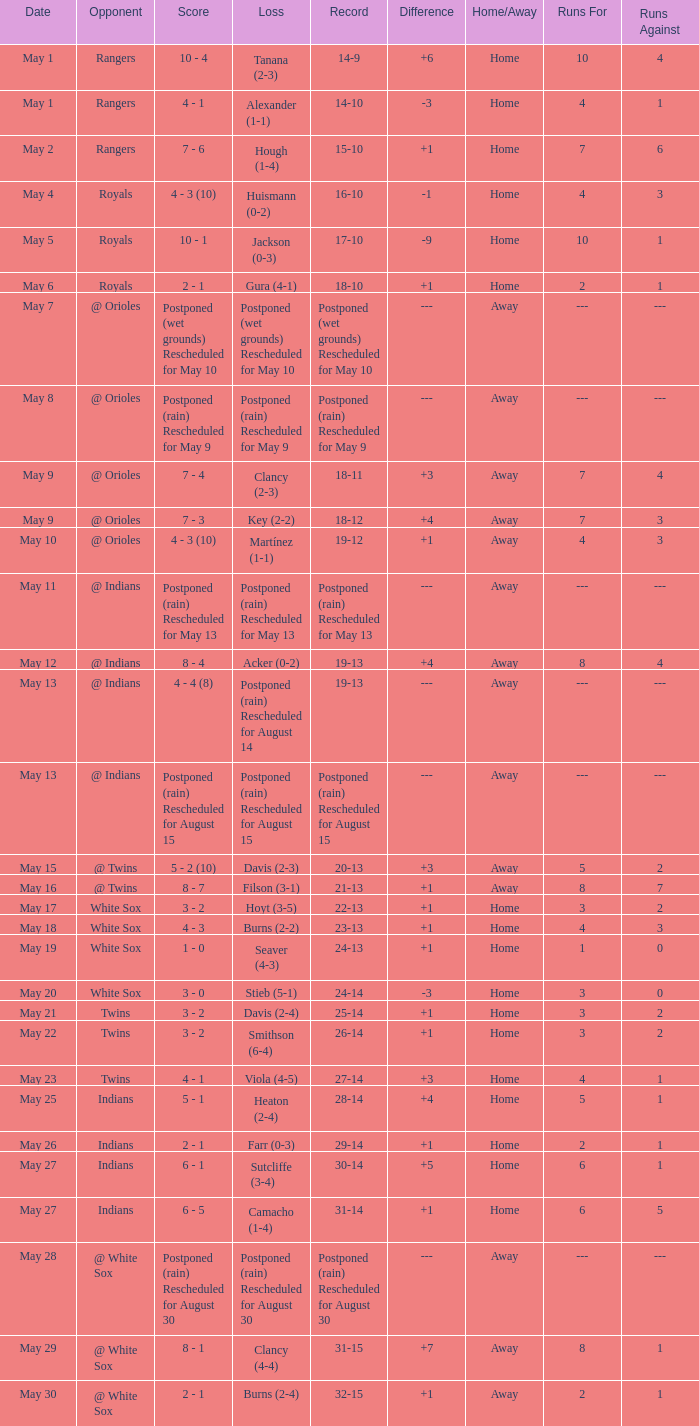What was the loss of the game when the record was 21-13? Filson (3-1). 